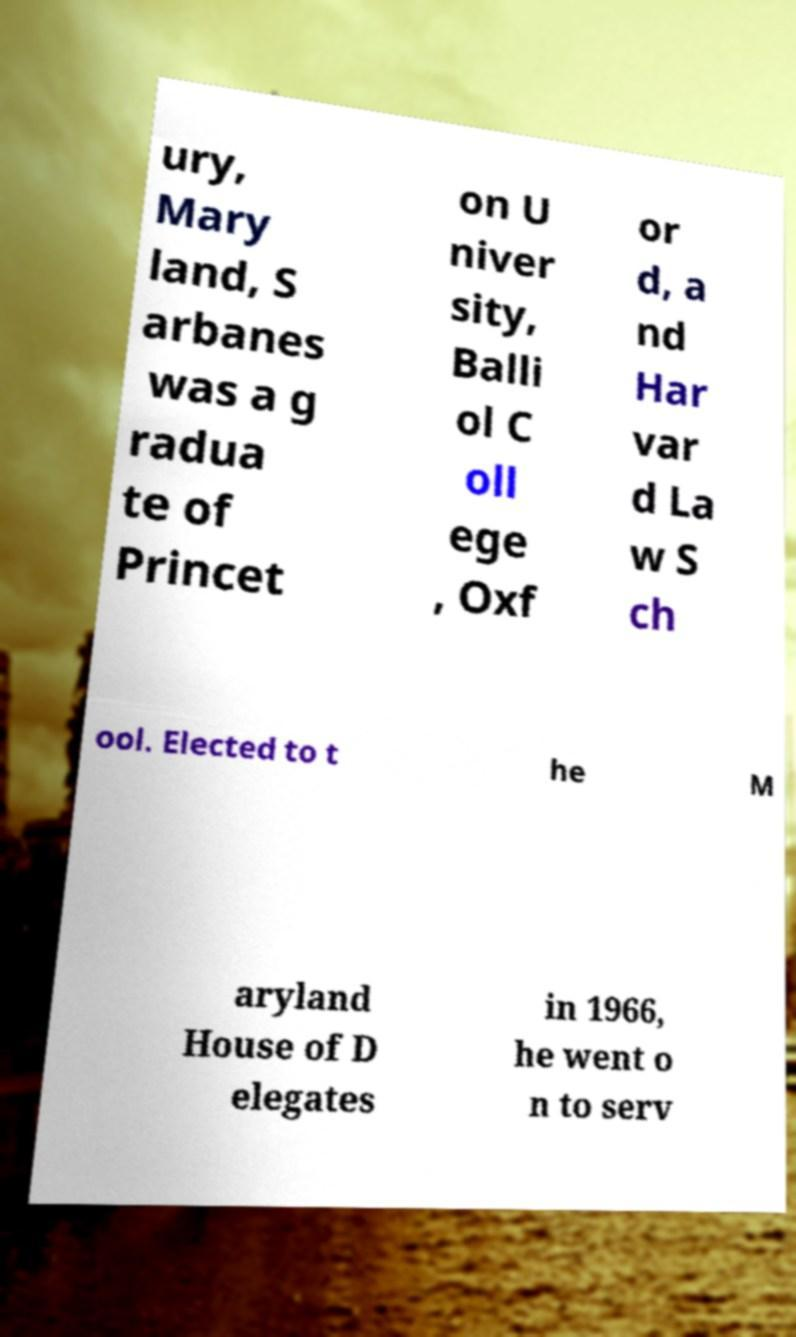Can you accurately transcribe the text from the provided image for me? ury, Mary land, S arbanes was a g radua te of Princet on U niver sity, Balli ol C oll ege , Oxf or d, a nd Har var d La w S ch ool. Elected to t he M aryland House of D elegates in 1966, he went o n to serv 